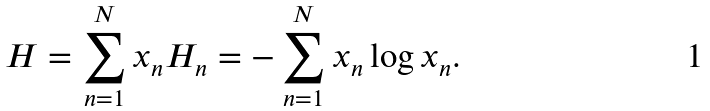<formula> <loc_0><loc_0><loc_500><loc_500>H = \sum _ { n = 1 } ^ { N } x _ { n } H _ { n } = - \sum _ { n = 1 } ^ { N } x _ { n } \log x _ { n } .</formula> 